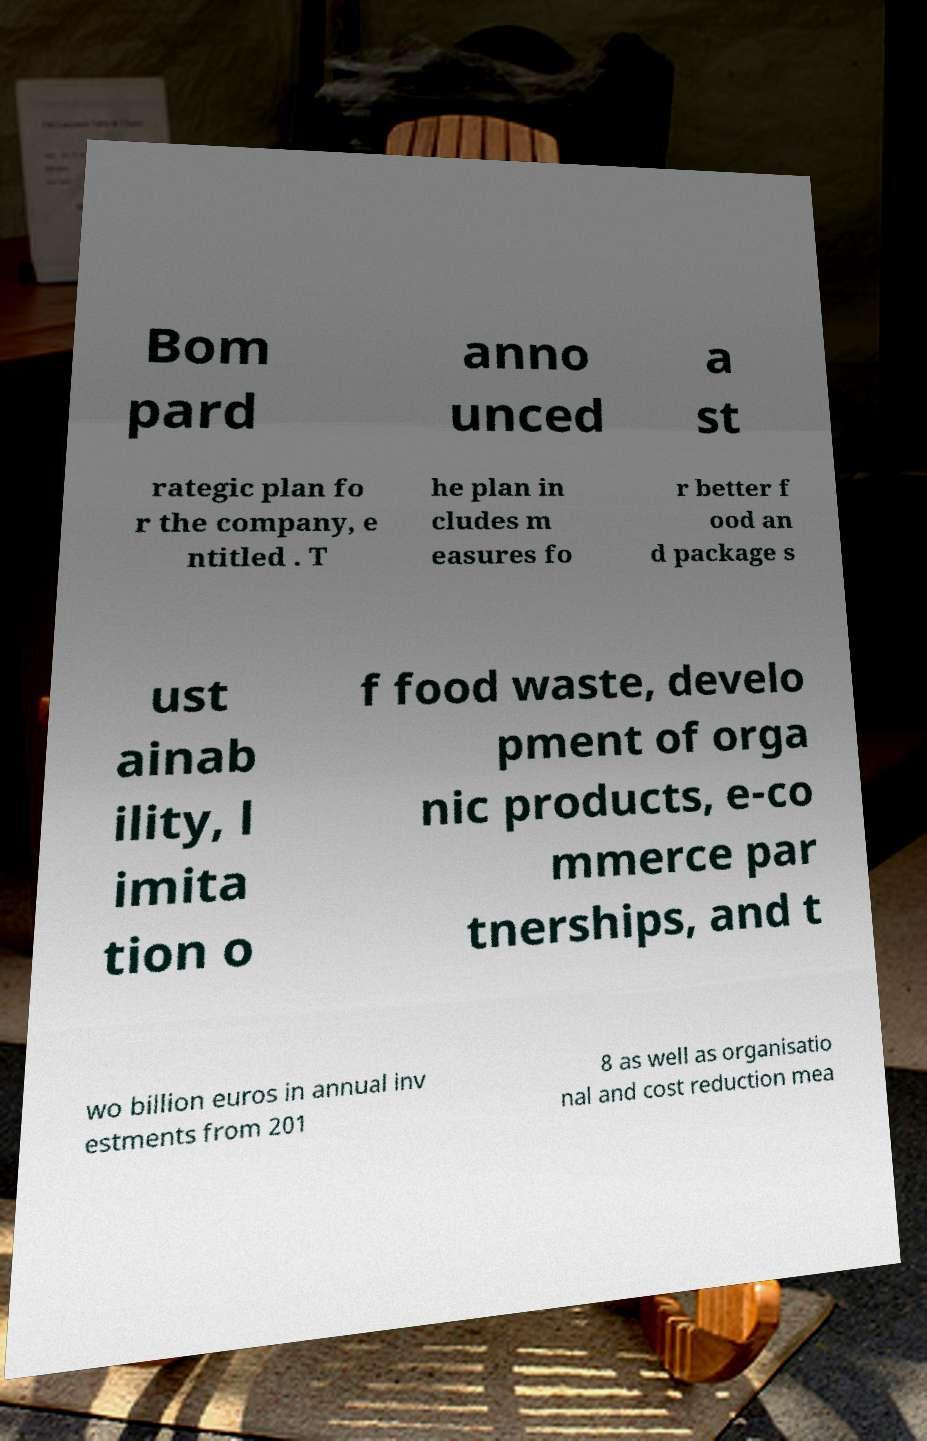Could you assist in decoding the text presented in this image and type it out clearly? Bom pard anno unced a st rategic plan fo r the company, e ntitled . T he plan in cludes m easures fo r better f ood an d package s ust ainab ility, l imita tion o f food waste, develo pment of orga nic products, e-co mmerce par tnerships, and t wo billion euros in annual inv estments from 201 8 as well as organisatio nal and cost reduction mea 